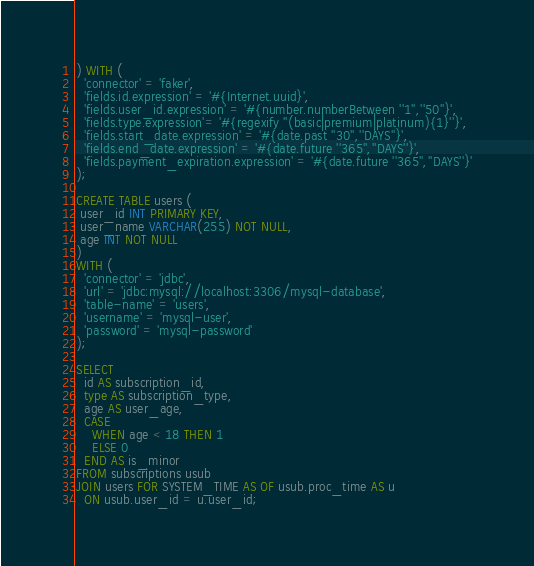Convert code to text. <code><loc_0><loc_0><loc_500><loc_500><_SQL_>) WITH (
  'connector' = 'faker',
  'fields.id.expression' = '#{Internet.uuid}',
  'fields.user_id.expression' = '#{number.numberBetween ''1'',''50''}',
  'fields.type.expression'= '#{regexify ''(basic|premium|platinum){1}''}',
  'fields.start_date.expression' = '#{date.past ''30'',''DAYS''}',
  'fields.end_date.expression' = '#{date.future ''365'',''DAYS''}',
  'fields.payment_expiration.expression' = '#{date.future ''365'',''DAYS''}'
);

CREATE TABLE users (
 user_id INT PRIMARY KEY,
 user_name VARCHAR(255) NOT NULL,
 age INT NOT NULL
)
WITH (
  'connector' = 'jdbc',
  'url' = 'jdbc:mysql://localhost:3306/mysql-database',
  'table-name' = 'users',
  'username' = 'mysql-user',
  'password' = 'mysql-password'
);

SELECT
  id AS subscription_id,
  type AS subscription_type,
  age AS user_age,
  CASE
    WHEN age < 18 THEN 1
    ELSE 0
  END AS is_minor
FROM subscriptions usub
JOIN users FOR SYSTEM_TIME AS OF usub.proc_time AS u
  ON usub.user_id = u.user_id;</code> 